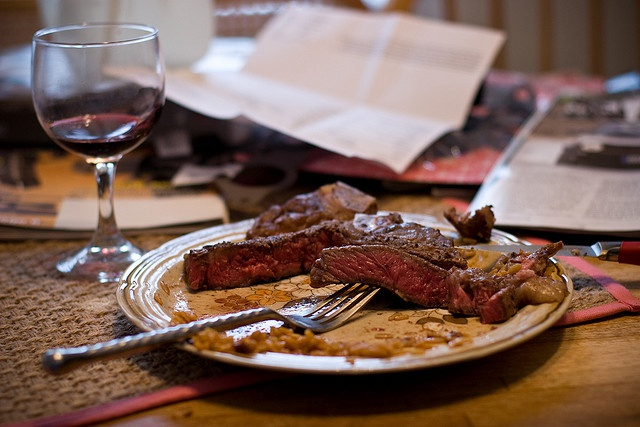Describe the objects in this image and their specific colors. I can see dining table in maroon, black, gray, and brown tones, wine glass in maroon, darkgray, gray, and black tones, book in maroon, darkgray, gray, and black tones, and fork in maroon, black, and gray tones in this image. 